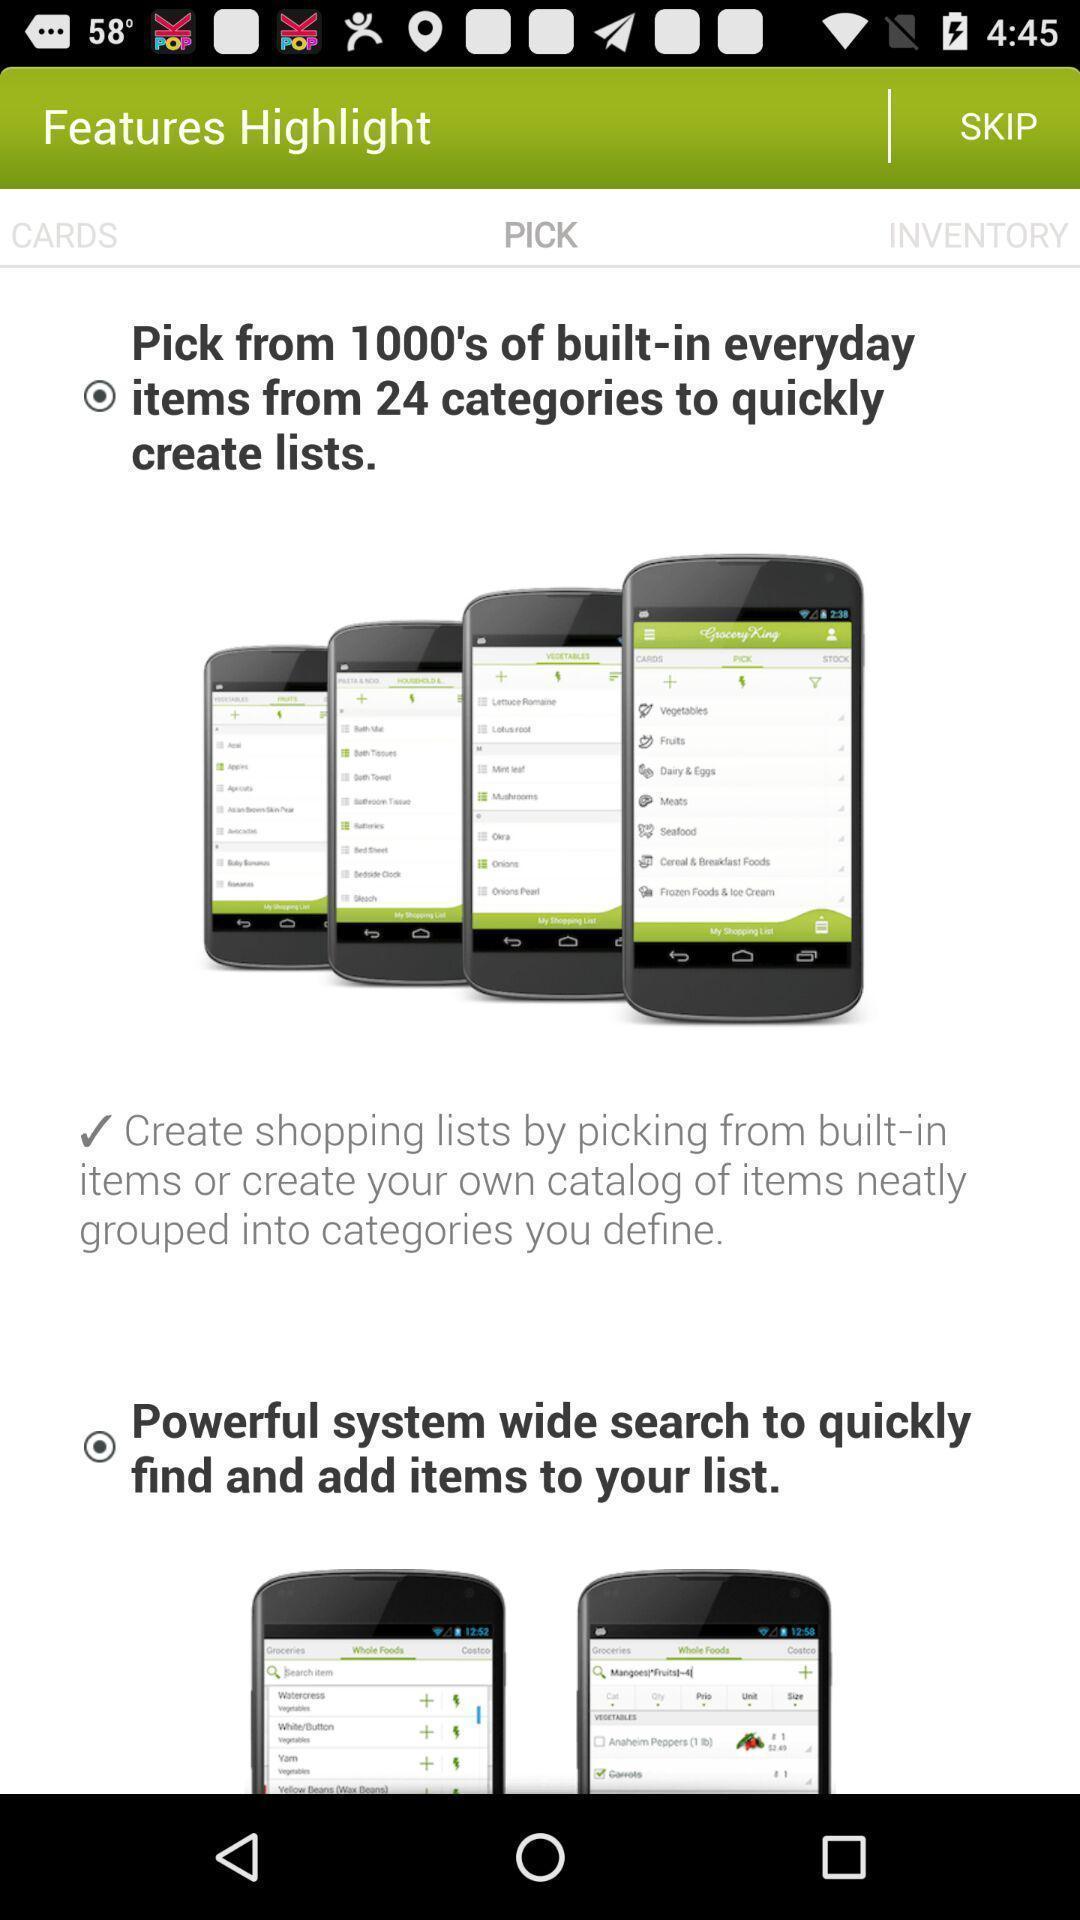Provide a description of this screenshot. Page showing the features highlights. 